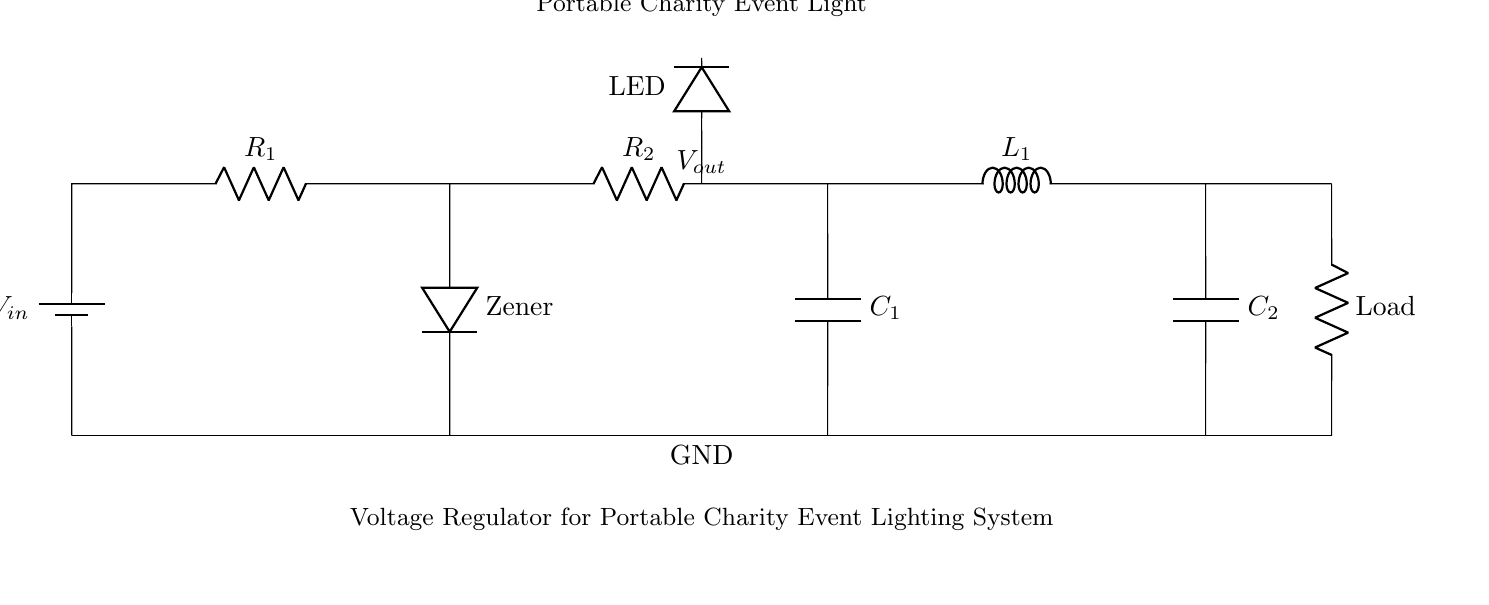What is the input voltage in this circuit? The input voltage is represented by the label V_in connected to the battery. It is the voltage supplied to the circuit.
Answer: V_in What type of diode is used in this circuit? The circuitry indicates that a Zener diode is used, as labeled next to the diode symbol in the diagram.
Answer: Zener What is the purpose of the capacitor C1? The capacitor C1, positioned after the resistor R2, helps to smooth out the voltage fluctuations, acting as a filter in the circuit.
Answer: Smoothing How many resistors are present in the circuit? By examining the diagram, we can count two distinct resistors R1 and R2, leading to the conclusion that there are two resistors in total.
Answer: Two What is the load in this voltage regulator circuit? The load is denoted with the label "Load" at the bottom right of the circuit diagram. It signifies where the power is ultimately delivered.
Answer: Load How do the capacitors affect the circuit? The two capacitors, C1 and C2, help manage voltage stability by smoothing and filtering while preventing fluctuations, which is crucial in regulating a stable output voltage.
Answer: Voltage stability What is the function of the inductor L1 in this circuit? The inductor L1 is typically used to store energy and smooth current flow, preventing sudden changes in current that could destabilize the circuit.
Answer: Smoothing 